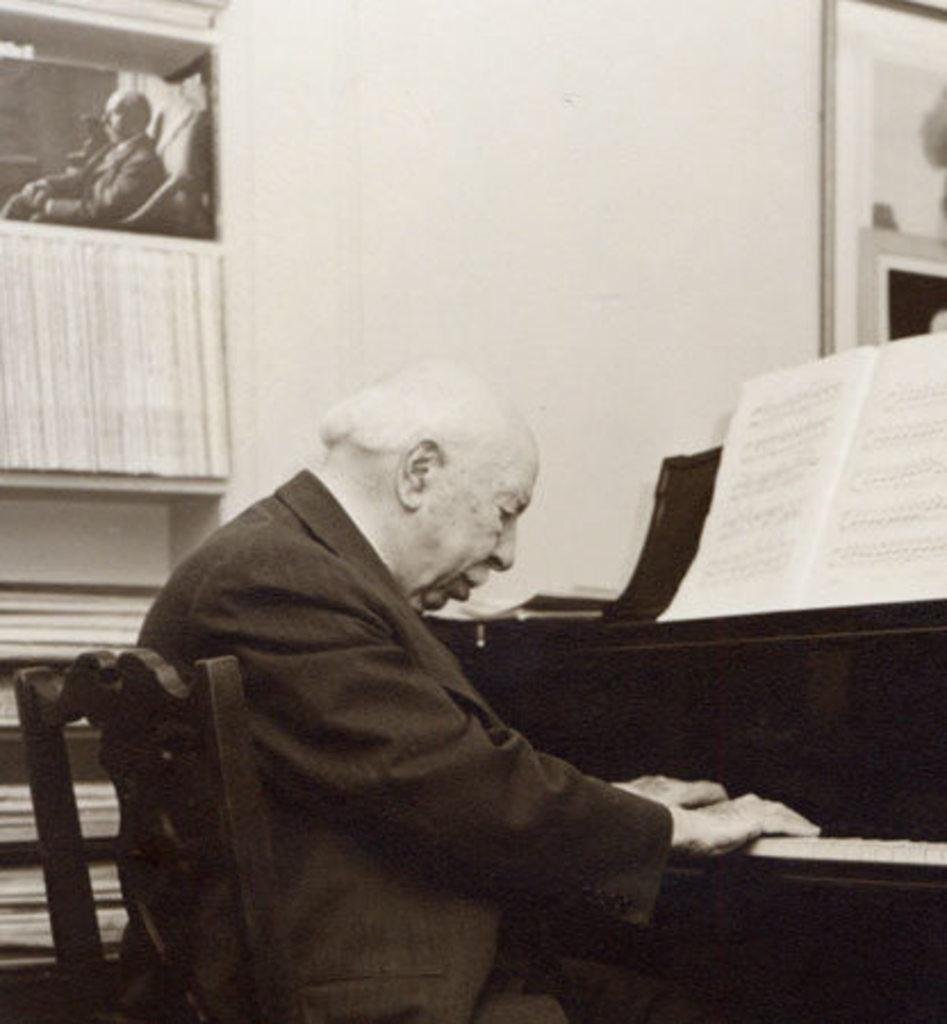What is the man in the image doing? The man is playing a keyboard. What is the man sitting on in the image? The man is seated on a chair. What object is in front of the man? There is a book in front of the man. What can be seen on the wall in the image? There is a wall frame on the wall. What type of beef is being served in the image? There is no beef present in the image; it features a man playing a keyboard, seated on a chair, with a book in front of him and a wall frame on the wall. 